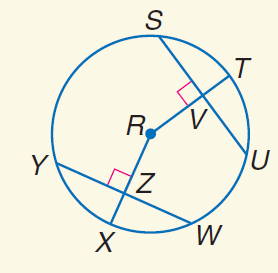Question: Triangles F G H and F H J are inscribed in \odot K with \widehat F G \cong \widehat F I. Find x if m \angle 1 = 6 x - 5, and m \angle 2 = 7 x + 4.
Choices:
A. 3
B. 7
C. 20
D. 30
Answer with the letter. Answer: B Question: In \odot R, S U = 20, Y W = 20, and m \widehat Y X = 45. Find m \widehat Y W.
Choices:
A. 20
B. 30
C. 45
D. 90
Answer with the letter. Answer: D Question: In \odot R, S U = 20, Y W = 20, and m \widehat Y X = 45. Find m \widehat S T.
Choices:
A. 20
B. 30
C. 45
D. 90
Answer with the letter. Answer: C Question: In \odot R, S U = 20, Y W = 20, and m \widehat Y X = 45. Find U V.
Choices:
A. 10
B. 20
C. 30
D. 45
Answer with the letter. Answer: A Question: In \odot R, S U = 20, Y W = 20, and m \widehat Y X = 45. Find W Z.
Choices:
A. 10
B. 20
C. 30
D. 45
Answer with the letter. Answer: A Question: In \odot R, S U = 20, Y W = 20, and m \widehat Y X = 45. Find S V.
Choices:
A. 10
B. 15
C. 20
D. 45
Answer with the letter. Answer: A Question: In \odot R, S U = 20, Y W = 20, and m \widehat Y X = 45. Find m \widehat S U.
Choices:
A. 20
B. 30
C. 45
D. 90
Answer with the letter. Answer: D 